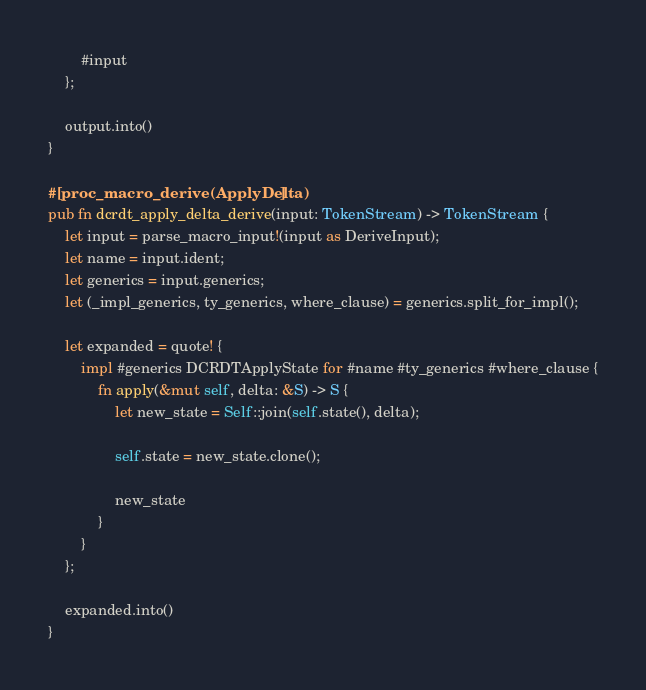Convert code to text. <code><loc_0><loc_0><loc_500><loc_500><_Rust_>
        #input
    };

    output.into()
}

#[proc_macro_derive(ApplyDelta)]
pub fn dcrdt_apply_delta_derive(input: TokenStream) -> TokenStream {
    let input = parse_macro_input!(input as DeriveInput);
    let name = input.ident;
    let generics = input.generics;
    let (_impl_generics, ty_generics, where_clause) = generics.split_for_impl();

    let expanded = quote! {
        impl #generics DCRDTApplyState for #name #ty_generics #where_clause {
            fn apply(&mut self, delta: &S) -> S {
                let new_state = Self::join(self.state(), delta);
        
                self.state = new_state.clone();
        
                new_state
            }
        }
    };

    expanded.into()
}
</code> 